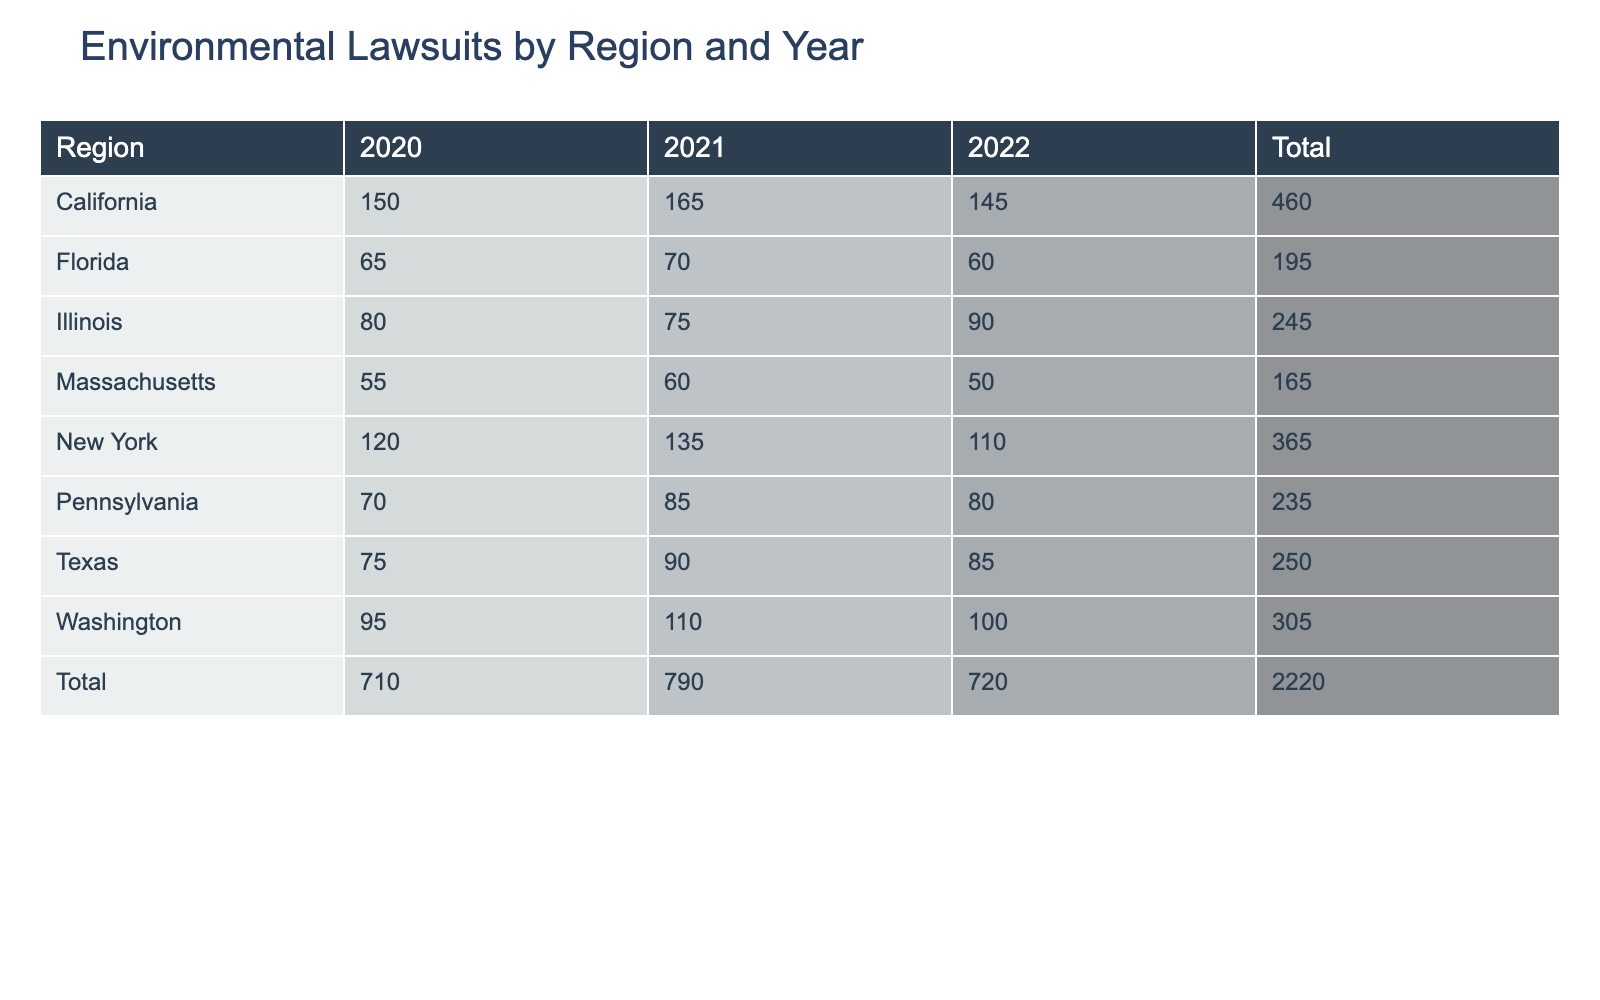What region had the highest number of lawsuits in 2021? Looking at the 2021 column in the table, California has the highest number of lawsuits with a total of 165 compared to other regions.
Answer: California What is the total number of environmental lawsuits filed in Texas over the three years? To find the total for Texas, we add the number of lawsuits for each year: 75 (2020) + 90 (2021) + 85 (2022) = 250.
Answer: 250 Which region experienced the largest increase in lawsuits from 2020 to 2021? By comparing the numbers for 2020 and 2021, California increased from 150 to 165, an increase of 15. New York increased from 120 to 135, which is 15 as well. However, Texas had a smaller increase of 15 from 75 to 90, and the others were lower or less. So, California has the largest absolute increase alongside New York, but California is the top due to its higher counts overall.
Answer: California and New York Was there a year when the lawsuits in Florida exceeded those in Massachusetts? Looking at the table, Florida's numbers for each year (65, 70, 60) do not exceed Massachusetts' numbers (55, 60, 50) in any year clearly. In fact, Florida's numbers are always higher than Massachusetts’, confirming the statement is true.
Answer: Yes What is the average number of lawsuits per region in 2022? First, we sum the number of lawsuits for 2022 across all regions: 145 (California) + 85 (Texas) + 110 (New York) + 60 (Florida) + 90 (Illinois) + 100 (Washington) + 50 (Massachusetts) + 80 (Pennsylvania) = 720. Then, we divide by the number of regions (8), which gives us an average of 720 / 8 = 90.
Answer: 90 Which region has the lowest number of total lawsuits across all years? By summing the values for each region from the total lawsuits: California (460), Texas (250), New York (365), Florida (195), Illinois (245), Washington (305), Massachusetts (165), and Pennsylvania (235). The lowest sum is for Massachusetts with a total of 165.
Answer: Massachusetts 